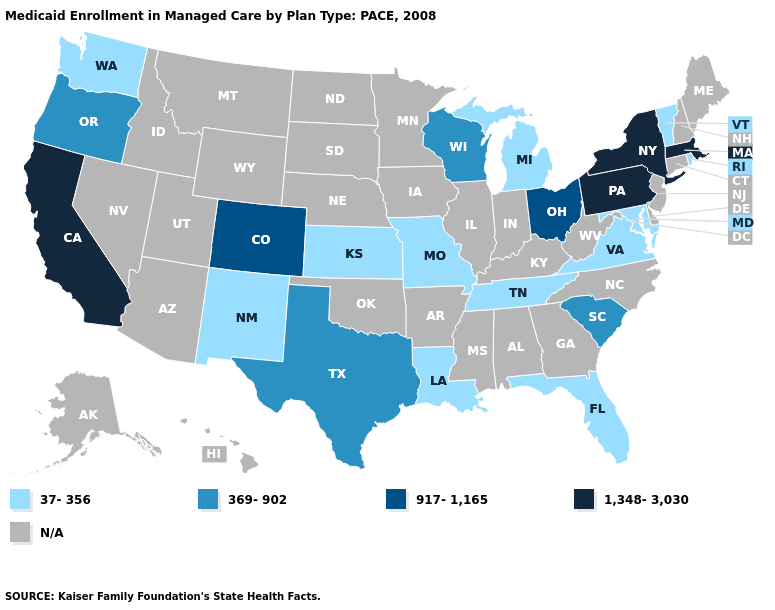What is the value of Montana?
Keep it brief. N/A. Name the states that have a value in the range 1,348-3,030?
Quick response, please. California, Massachusetts, New York, Pennsylvania. Which states have the lowest value in the West?
Be succinct. New Mexico, Washington. Name the states that have a value in the range 37-356?
Give a very brief answer. Florida, Kansas, Louisiana, Maryland, Michigan, Missouri, New Mexico, Rhode Island, Tennessee, Vermont, Virginia, Washington. What is the value of Virginia?
Be succinct. 37-356. Name the states that have a value in the range 1,348-3,030?
Keep it brief. California, Massachusetts, New York, Pennsylvania. What is the highest value in states that border Arkansas?
Concise answer only. 369-902. Which states have the lowest value in the USA?
Answer briefly. Florida, Kansas, Louisiana, Maryland, Michigan, Missouri, New Mexico, Rhode Island, Tennessee, Vermont, Virginia, Washington. What is the highest value in the West ?
Answer briefly. 1,348-3,030. Which states have the highest value in the USA?
Short answer required. California, Massachusetts, New York, Pennsylvania. Name the states that have a value in the range 37-356?
Concise answer only. Florida, Kansas, Louisiana, Maryland, Michigan, Missouri, New Mexico, Rhode Island, Tennessee, Vermont, Virginia, Washington. Name the states that have a value in the range 917-1,165?
Keep it brief. Colorado, Ohio. 